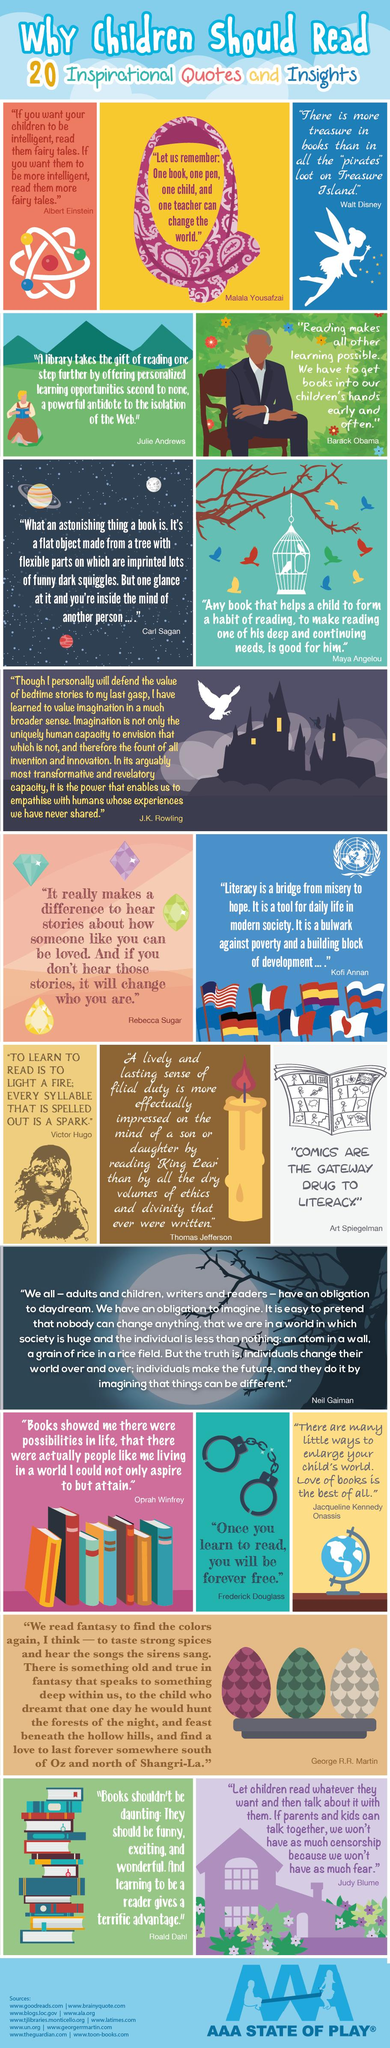Specify some key components in this picture. There are 20 quotes in the image. 